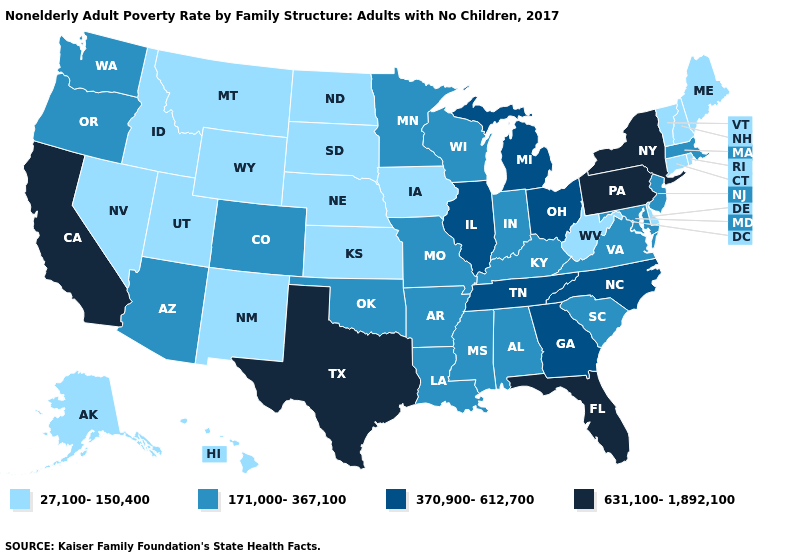Does North Carolina have a higher value than New York?
Answer briefly. No. Name the states that have a value in the range 631,100-1,892,100?
Keep it brief. California, Florida, New York, Pennsylvania, Texas. Which states have the lowest value in the USA?
Quick response, please. Alaska, Connecticut, Delaware, Hawaii, Idaho, Iowa, Kansas, Maine, Montana, Nebraska, Nevada, New Hampshire, New Mexico, North Dakota, Rhode Island, South Dakota, Utah, Vermont, West Virginia, Wyoming. Does Texas have the lowest value in the USA?
Concise answer only. No. Does Illinois have the lowest value in the MidWest?
Be succinct. No. What is the value of Connecticut?
Concise answer only. 27,100-150,400. What is the value of Utah?
Short answer required. 27,100-150,400. Name the states that have a value in the range 631,100-1,892,100?
Quick response, please. California, Florida, New York, Pennsylvania, Texas. Does Alabama have the lowest value in the USA?
Short answer required. No. Name the states that have a value in the range 27,100-150,400?
Keep it brief. Alaska, Connecticut, Delaware, Hawaii, Idaho, Iowa, Kansas, Maine, Montana, Nebraska, Nevada, New Hampshire, New Mexico, North Dakota, Rhode Island, South Dakota, Utah, Vermont, West Virginia, Wyoming. Does Louisiana have the lowest value in the USA?
Quick response, please. No. Is the legend a continuous bar?
Short answer required. No. Which states have the lowest value in the USA?
Quick response, please. Alaska, Connecticut, Delaware, Hawaii, Idaho, Iowa, Kansas, Maine, Montana, Nebraska, Nevada, New Hampshire, New Mexico, North Dakota, Rhode Island, South Dakota, Utah, Vermont, West Virginia, Wyoming. What is the value of New York?
Concise answer only. 631,100-1,892,100. Does Hawaii have the same value as Nevada?
Give a very brief answer. Yes. 